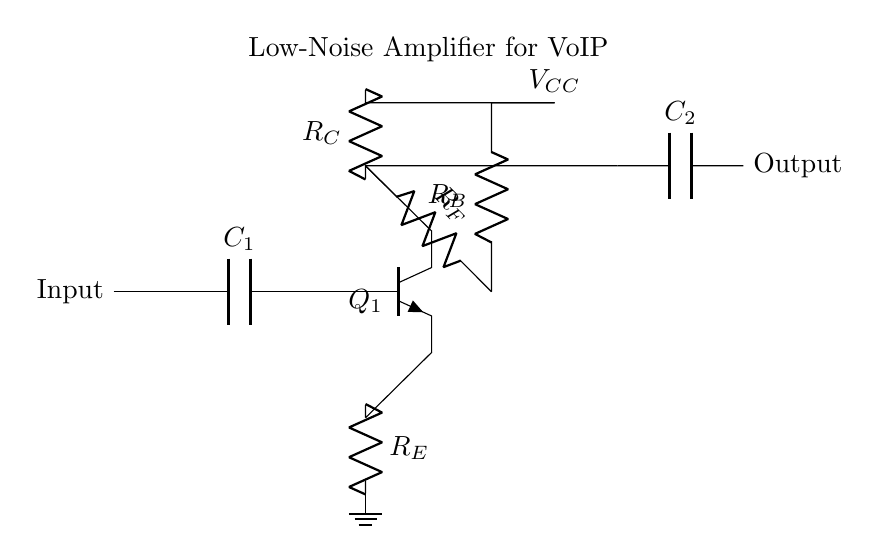What is the function of capacitor C1 in this circuit? Capacitor C1 serves as a coupling capacitor to block any DC offset while allowing AC signals to pass through to the amplifier input.
Answer: Coupling capacitor What type of transistor is used in this amplifier design? The circuit diagram indicates the use of an NPN transistor for amplification, which is evident from the labeling of the transistor in the diagram.
Answer: NPN What is the purpose of resistor R_E in this circuit? Resistor R_E provides emitter degeneration, which helps stabilize the gain of the amplifier, reducing the effects of temperature variations and transistor parameter changes.
Answer: Emitter degeneration What is the biasing voltage represented as V_CC in the circuit? V_CC is the supply voltage connected to the collector of the transistor, which is essential for its operation by providing the necessary energy for amplification.
Answer: Supply voltage What role does resistor R_F play in the amplifier circuit? Resistor R_F is part of the feedback network that helps control the gain of the amplifier, ensuring stability and determining the output level in relation to the input signal.
Answer: Feedback resistor How many capacitors are present in this circuit diagram? There are two capacitors shown in the circuit, one at the input (C1) and one at the output (C2).
Answer: Two What do the labels "input" and "output" signify in this circuit? The labels indicate the entry point for the input audio signal and the exit point for the amplified audio signal, respectively, essential for VoIP communication.
Answer: Signal entry and exit 